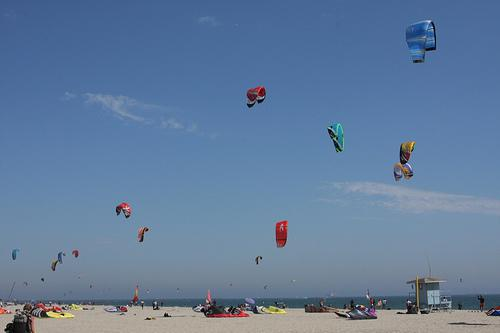Question: what are they flying?
Choices:
A. Kite.
B. A ballon.
C. A rc plane.
D. A hang glider.
Answer with the letter. Answer: A Question: where are they Flying kites at?
Choices:
A. A beach.
B. A meadow.
C. A park.
D. A back yard.
Answer with the letter. Answer: A Question: who are flying the kites?
Choices:
A. Kids.
B. Friends.
C. People.
D. Cousins.
Answer with the letter. Answer: C Question: what kind of day is it?
Choices:
A. Sunny.
B. Rainy.
C. Windy.
D. Cloudy.
Answer with the letter. Answer: A 